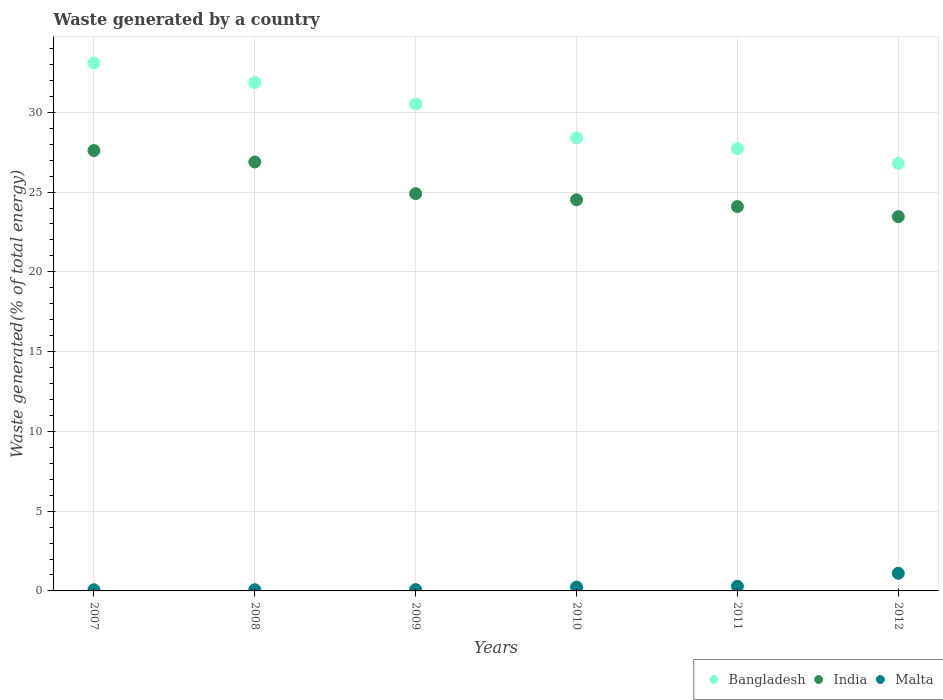What is the total waste generated in Malta in 2010?
Make the answer very short. 0.24. Across all years, what is the maximum total waste generated in Malta?
Provide a succinct answer. 1.11. Across all years, what is the minimum total waste generated in India?
Your response must be concise. 23.46. In which year was the total waste generated in Malta minimum?
Provide a short and direct response. 2007. What is the total total waste generated in Bangladesh in the graph?
Give a very brief answer. 178.39. What is the difference between the total waste generated in Malta in 2007 and that in 2010?
Provide a short and direct response. -0.17. What is the difference between the total waste generated in Malta in 2012 and the total waste generated in Bangladesh in 2008?
Give a very brief answer. -30.76. What is the average total waste generated in Bangladesh per year?
Offer a very short reply. 29.73. In the year 2011, what is the difference between the total waste generated in Bangladesh and total waste generated in India?
Provide a succinct answer. 3.63. In how many years, is the total waste generated in Bangladesh greater than 27 %?
Offer a terse response. 5. What is the ratio of the total waste generated in Malta in 2007 to that in 2008?
Give a very brief answer. 0.95. Is the total waste generated in India in 2007 less than that in 2012?
Your answer should be very brief. No. What is the difference between the highest and the second highest total waste generated in Malta?
Your answer should be compact. 0.82. What is the difference between the highest and the lowest total waste generated in India?
Your answer should be very brief. 4.14. Is the sum of the total waste generated in India in 2008 and 2009 greater than the maximum total waste generated in Malta across all years?
Keep it short and to the point. Yes. Is it the case that in every year, the sum of the total waste generated in Malta and total waste generated in India  is greater than the total waste generated in Bangladesh?
Your answer should be compact. No. Does the total waste generated in Bangladesh monotonically increase over the years?
Give a very brief answer. No. Is the total waste generated in Bangladesh strictly less than the total waste generated in India over the years?
Offer a very short reply. No. How many years are there in the graph?
Keep it short and to the point. 6. Are the values on the major ticks of Y-axis written in scientific E-notation?
Your response must be concise. No. Does the graph contain any zero values?
Your response must be concise. No. How are the legend labels stacked?
Provide a succinct answer. Horizontal. What is the title of the graph?
Make the answer very short. Waste generated by a country. What is the label or title of the X-axis?
Offer a very short reply. Years. What is the label or title of the Y-axis?
Keep it short and to the point. Waste generated(% of total energy). What is the Waste generated(% of total energy) in Bangladesh in 2007?
Provide a short and direct response. 33.09. What is the Waste generated(% of total energy) in India in 2007?
Your response must be concise. 27.6. What is the Waste generated(% of total energy) of Malta in 2007?
Provide a short and direct response. 0.07. What is the Waste generated(% of total energy) in Bangladesh in 2008?
Offer a terse response. 31.86. What is the Waste generated(% of total energy) in India in 2008?
Give a very brief answer. 26.88. What is the Waste generated(% of total energy) in Malta in 2008?
Your response must be concise. 0.07. What is the Waste generated(% of total energy) of Bangladesh in 2009?
Provide a succinct answer. 30.52. What is the Waste generated(% of total energy) in India in 2009?
Your response must be concise. 24.9. What is the Waste generated(% of total energy) of Malta in 2009?
Provide a succinct answer. 0.08. What is the Waste generated(% of total energy) of Bangladesh in 2010?
Your response must be concise. 28.4. What is the Waste generated(% of total energy) of India in 2010?
Make the answer very short. 24.51. What is the Waste generated(% of total energy) in Malta in 2010?
Provide a succinct answer. 0.24. What is the Waste generated(% of total energy) in Bangladesh in 2011?
Your answer should be compact. 27.72. What is the Waste generated(% of total energy) in India in 2011?
Give a very brief answer. 24.09. What is the Waste generated(% of total energy) of Malta in 2011?
Make the answer very short. 0.29. What is the Waste generated(% of total energy) of Bangladesh in 2012?
Give a very brief answer. 26.8. What is the Waste generated(% of total energy) of India in 2012?
Offer a very short reply. 23.46. What is the Waste generated(% of total energy) in Malta in 2012?
Ensure brevity in your answer.  1.11. Across all years, what is the maximum Waste generated(% of total energy) of Bangladesh?
Your answer should be compact. 33.09. Across all years, what is the maximum Waste generated(% of total energy) in India?
Your answer should be compact. 27.6. Across all years, what is the maximum Waste generated(% of total energy) in Malta?
Make the answer very short. 1.11. Across all years, what is the minimum Waste generated(% of total energy) in Bangladesh?
Provide a succinct answer. 26.8. Across all years, what is the minimum Waste generated(% of total energy) of India?
Your answer should be compact. 23.46. Across all years, what is the minimum Waste generated(% of total energy) in Malta?
Offer a very short reply. 0.07. What is the total Waste generated(% of total energy) in Bangladesh in the graph?
Your answer should be very brief. 178.39. What is the total Waste generated(% of total energy) in India in the graph?
Give a very brief answer. 151.45. What is the total Waste generated(% of total energy) in Malta in the graph?
Ensure brevity in your answer.  1.86. What is the difference between the Waste generated(% of total energy) of Bangladesh in 2007 and that in 2008?
Offer a terse response. 1.23. What is the difference between the Waste generated(% of total energy) in India in 2007 and that in 2008?
Your answer should be compact. 0.72. What is the difference between the Waste generated(% of total energy) in Malta in 2007 and that in 2008?
Your answer should be very brief. -0. What is the difference between the Waste generated(% of total energy) in Bangladesh in 2007 and that in 2009?
Your response must be concise. 2.58. What is the difference between the Waste generated(% of total energy) in India in 2007 and that in 2009?
Offer a very short reply. 2.7. What is the difference between the Waste generated(% of total energy) of Malta in 2007 and that in 2009?
Ensure brevity in your answer.  -0.01. What is the difference between the Waste generated(% of total energy) in Bangladesh in 2007 and that in 2010?
Your response must be concise. 4.7. What is the difference between the Waste generated(% of total energy) of India in 2007 and that in 2010?
Offer a very short reply. 3.09. What is the difference between the Waste generated(% of total energy) in Malta in 2007 and that in 2010?
Offer a terse response. -0.17. What is the difference between the Waste generated(% of total energy) in Bangladesh in 2007 and that in 2011?
Your answer should be very brief. 5.38. What is the difference between the Waste generated(% of total energy) in India in 2007 and that in 2011?
Give a very brief answer. 3.51. What is the difference between the Waste generated(% of total energy) of Malta in 2007 and that in 2011?
Your response must be concise. -0.22. What is the difference between the Waste generated(% of total energy) of Bangladesh in 2007 and that in 2012?
Offer a very short reply. 6.29. What is the difference between the Waste generated(% of total energy) in India in 2007 and that in 2012?
Your answer should be compact. 4.14. What is the difference between the Waste generated(% of total energy) of Malta in 2007 and that in 2012?
Make the answer very short. -1.04. What is the difference between the Waste generated(% of total energy) of Bangladesh in 2008 and that in 2009?
Give a very brief answer. 1.35. What is the difference between the Waste generated(% of total energy) in India in 2008 and that in 2009?
Ensure brevity in your answer.  1.98. What is the difference between the Waste generated(% of total energy) in Malta in 2008 and that in 2009?
Make the answer very short. -0.01. What is the difference between the Waste generated(% of total energy) in Bangladesh in 2008 and that in 2010?
Keep it short and to the point. 3.47. What is the difference between the Waste generated(% of total energy) of India in 2008 and that in 2010?
Give a very brief answer. 2.37. What is the difference between the Waste generated(% of total energy) of Malta in 2008 and that in 2010?
Offer a very short reply. -0.16. What is the difference between the Waste generated(% of total energy) in Bangladesh in 2008 and that in 2011?
Your answer should be very brief. 4.15. What is the difference between the Waste generated(% of total energy) of India in 2008 and that in 2011?
Offer a very short reply. 2.79. What is the difference between the Waste generated(% of total energy) in Malta in 2008 and that in 2011?
Provide a short and direct response. -0.22. What is the difference between the Waste generated(% of total energy) of Bangladesh in 2008 and that in 2012?
Ensure brevity in your answer.  5.06. What is the difference between the Waste generated(% of total energy) in India in 2008 and that in 2012?
Give a very brief answer. 3.42. What is the difference between the Waste generated(% of total energy) in Malta in 2008 and that in 2012?
Your answer should be very brief. -1.03. What is the difference between the Waste generated(% of total energy) of Bangladesh in 2009 and that in 2010?
Your answer should be compact. 2.12. What is the difference between the Waste generated(% of total energy) of India in 2009 and that in 2010?
Make the answer very short. 0.39. What is the difference between the Waste generated(% of total energy) in Malta in 2009 and that in 2010?
Give a very brief answer. -0.16. What is the difference between the Waste generated(% of total energy) in Bangladesh in 2009 and that in 2011?
Your answer should be very brief. 2.8. What is the difference between the Waste generated(% of total energy) of India in 2009 and that in 2011?
Keep it short and to the point. 0.81. What is the difference between the Waste generated(% of total energy) of Malta in 2009 and that in 2011?
Your answer should be very brief. -0.21. What is the difference between the Waste generated(% of total energy) in Bangladesh in 2009 and that in 2012?
Your answer should be very brief. 3.72. What is the difference between the Waste generated(% of total energy) of India in 2009 and that in 2012?
Your response must be concise. 1.44. What is the difference between the Waste generated(% of total energy) of Malta in 2009 and that in 2012?
Offer a very short reply. -1.03. What is the difference between the Waste generated(% of total energy) of Bangladesh in 2010 and that in 2011?
Your response must be concise. 0.68. What is the difference between the Waste generated(% of total energy) in India in 2010 and that in 2011?
Give a very brief answer. 0.42. What is the difference between the Waste generated(% of total energy) in Malta in 2010 and that in 2011?
Your answer should be very brief. -0.05. What is the difference between the Waste generated(% of total energy) in Bangladesh in 2010 and that in 2012?
Ensure brevity in your answer.  1.6. What is the difference between the Waste generated(% of total energy) of India in 2010 and that in 2012?
Your response must be concise. 1.05. What is the difference between the Waste generated(% of total energy) of Malta in 2010 and that in 2012?
Make the answer very short. -0.87. What is the difference between the Waste generated(% of total energy) of Bangladesh in 2011 and that in 2012?
Your answer should be compact. 0.92. What is the difference between the Waste generated(% of total energy) of India in 2011 and that in 2012?
Offer a very short reply. 0.63. What is the difference between the Waste generated(% of total energy) of Malta in 2011 and that in 2012?
Ensure brevity in your answer.  -0.82. What is the difference between the Waste generated(% of total energy) in Bangladesh in 2007 and the Waste generated(% of total energy) in India in 2008?
Provide a short and direct response. 6.21. What is the difference between the Waste generated(% of total energy) of Bangladesh in 2007 and the Waste generated(% of total energy) of Malta in 2008?
Keep it short and to the point. 33.02. What is the difference between the Waste generated(% of total energy) in India in 2007 and the Waste generated(% of total energy) in Malta in 2008?
Ensure brevity in your answer.  27.53. What is the difference between the Waste generated(% of total energy) in Bangladesh in 2007 and the Waste generated(% of total energy) in India in 2009?
Keep it short and to the point. 8.19. What is the difference between the Waste generated(% of total energy) in Bangladesh in 2007 and the Waste generated(% of total energy) in Malta in 2009?
Ensure brevity in your answer.  33.01. What is the difference between the Waste generated(% of total energy) of India in 2007 and the Waste generated(% of total energy) of Malta in 2009?
Offer a very short reply. 27.52. What is the difference between the Waste generated(% of total energy) of Bangladesh in 2007 and the Waste generated(% of total energy) of India in 2010?
Provide a succinct answer. 8.58. What is the difference between the Waste generated(% of total energy) of Bangladesh in 2007 and the Waste generated(% of total energy) of Malta in 2010?
Ensure brevity in your answer.  32.86. What is the difference between the Waste generated(% of total energy) in India in 2007 and the Waste generated(% of total energy) in Malta in 2010?
Keep it short and to the point. 27.36. What is the difference between the Waste generated(% of total energy) in Bangladesh in 2007 and the Waste generated(% of total energy) in India in 2011?
Ensure brevity in your answer.  9. What is the difference between the Waste generated(% of total energy) in Bangladesh in 2007 and the Waste generated(% of total energy) in Malta in 2011?
Your response must be concise. 32.8. What is the difference between the Waste generated(% of total energy) of India in 2007 and the Waste generated(% of total energy) of Malta in 2011?
Make the answer very short. 27.31. What is the difference between the Waste generated(% of total energy) of Bangladesh in 2007 and the Waste generated(% of total energy) of India in 2012?
Offer a terse response. 9.63. What is the difference between the Waste generated(% of total energy) of Bangladesh in 2007 and the Waste generated(% of total energy) of Malta in 2012?
Offer a very short reply. 31.99. What is the difference between the Waste generated(% of total energy) of India in 2007 and the Waste generated(% of total energy) of Malta in 2012?
Provide a succinct answer. 26.49. What is the difference between the Waste generated(% of total energy) in Bangladesh in 2008 and the Waste generated(% of total energy) in India in 2009?
Keep it short and to the point. 6.96. What is the difference between the Waste generated(% of total energy) in Bangladesh in 2008 and the Waste generated(% of total energy) in Malta in 2009?
Your response must be concise. 31.78. What is the difference between the Waste generated(% of total energy) of India in 2008 and the Waste generated(% of total energy) of Malta in 2009?
Offer a very short reply. 26.8. What is the difference between the Waste generated(% of total energy) of Bangladesh in 2008 and the Waste generated(% of total energy) of India in 2010?
Offer a very short reply. 7.35. What is the difference between the Waste generated(% of total energy) in Bangladesh in 2008 and the Waste generated(% of total energy) in Malta in 2010?
Keep it short and to the point. 31.63. What is the difference between the Waste generated(% of total energy) of India in 2008 and the Waste generated(% of total energy) of Malta in 2010?
Offer a terse response. 26.65. What is the difference between the Waste generated(% of total energy) of Bangladesh in 2008 and the Waste generated(% of total energy) of India in 2011?
Give a very brief answer. 7.77. What is the difference between the Waste generated(% of total energy) in Bangladesh in 2008 and the Waste generated(% of total energy) in Malta in 2011?
Provide a short and direct response. 31.57. What is the difference between the Waste generated(% of total energy) of India in 2008 and the Waste generated(% of total energy) of Malta in 2011?
Your answer should be compact. 26.59. What is the difference between the Waste generated(% of total energy) in Bangladesh in 2008 and the Waste generated(% of total energy) in India in 2012?
Keep it short and to the point. 8.4. What is the difference between the Waste generated(% of total energy) in Bangladesh in 2008 and the Waste generated(% of total energy) in Malta in 2012?
Your answer should be very brief. 30.76. What is the difference between the Waste generated(% of total energy) in India in 2008 and the Waste generated(% of total energy) in Malta in 2012?
Provide a succinct answer. 25.78. What is the difference between the Waste generated(% of total energy) in Bangladesh in 2009 and the Waste generated(% of total energy) in India in 2010?
Provide a succinct answer. 6. What is the difference between the Waste generated(% of total energy) in Bangladesh in 2009 and the Waste generated(% of total energy) in Malta in 2010?
Provide a succinct answer. 30.28. What is the difference between the Waste generated(% of total energy) of India in 2009 and the Waste generated(% of total energy) of Malta in 2010?
Keep it short and to the point. 24.66. What is the difference between the Waste generated(% of total energy) in Bangladesh in 2009 and the Waste generated(% of total energy) in India in 2011?
Your answer should be very brief. 6.43. What is the difference between the Waste generated(% of total energy) of Bangladesh in 2009 and the Waste generated(% of total energy) of Malta in 2011?
Your answer should be very brief. 30.23. What is the difference between the Waste generated(% of total energy) in India in 2009 and the Waste generated(% of total energy) in Malta in 2011?
Your answer should be compact. 24.61. What is the difference between the Waste generated(% of total energy) in Bangladesh in 2009 and the Waste generated(% of total energy) in India in 2012?
Offer a very short reply. 7.06. What is the difference between the Waste generated(% of total energy) in Bangladesh in 2009 and the Waste generated(% of total energy) in Malta in 2012?
Give a very brief answer. 29.41. What is the difference between the Waste generated(% of total energy) in India in 2009 and the Waste generated(% of total energy) in Malta in 2012?
Keep it short and to the point. 23.79. What is the difference between the Waste generated(% of total energy) of Bangladesh in 2010 and the Waste generated(% of total energy) of India in 2011?
Offer a very short reply. 4.31. What is the difference between the Waste generated(% of total energy) of Bangladesh in 2010 and the Waste generated(% of total energy) of Malta in 2011?
Keep it short and to the point. 28.1. What is the difference between the Waste generated(% of total energy) in India in 2010 and the Waste generated(% of total energy) in Malta in 2011?
Keep it short and to the point. 24.22. What is the difference between the Waste generated(% of total energy) in Bangladesh in 2010 and the Waste generated(% of total energy) in India in 2012?
Offer a terse response. 4.94. What is the difference between the Waste generated(% of total energy) of Bangladesh in 2010 and the Waste generated(% of total energy) of Malta in 2012?
Offer a terse response. 27.29. What is the difference between the Waste generated(% of total energy) of India in 2010 and the Waste generated(% of total energy) of Malta in 2012?
Provide a succinct answer. 23.41. What is the difference between the Waste generated(% of total energy) in Bangladesh in 2011 and the Waste generated(% of total energy) in India in 2012?
Ensure brevity in your answer.  4.26. What is the difference between the Waste generated(% of total energy) of Bangladesh in 2011 and the Waste generated(% of total energy) of Malta in 2012?
Ensure brevity in your answer.  26.61. What is the difference between the Waste generated(% of total energy) of India in 2011 and the Waste generated(% of total energy) of Malta in 2012?
Provide a succinct answer. 22.98. What is the average Waste generated(% of total energy) of Bangladesh per year?
Make the answer very short. 29.73. What is the average Waste generated(% of total energy) in India per year?
Offer a very short reply. 25.24. What is the average Waste generated(% of total energy) of Malta per year?
Offer a terse response. 0.31. In the year 2007, what is the difference between the Waste generated(% of total energy) of Bangladesh and Waste generated(% of total energy) of India?
Provide a succinct answer. 5.49. In the year 2007, what is the difference between the Waste generated(% of total energy) of Bangladesh and Waste generated(% of total energy) of Malta?
Provide a succinct answer. 33.02. In the year 2007, what is the difference between the Waste generated(% of total energy) of India and Waste generated(% of total energy) of Malta?
Offer a very short reply. 27.53. In the year 2008, what is the difference between the Waste generated(% of total energy) in Bangladesh and Waste generated(% of total energy) in India?
Your answer should be very brief. 4.98. In the year 2008, what is the difference between the Waste generated(% of total energy) in Bangladesh and Waste generated(% of total energy) in Malta?
Your response must be concise. 31.79. In the year 2008, what is the difference between the Waste generated(% of total energy) of India and Waste generated(% of total energy) of Malta?
Provide a succinct answer. 26.81. In the year 2009, what is the difference between the Waste generated(% of total energy) in Bangladesh and Waste generated(% of total energy) in India?
Provide a succinct answer. 5.62. In the year 2009, what is the difference between the Waste generated(% of total energy) of Bangladesh and Waste generated(% of total energy) of Malta?
Your answer should be very brief. 30.44. In the year 2009, what is the difference between the Waste generated(% of total energy) of India and Waste generated(% of total energy) of Malta?
Make the answer very short. 24.82. In the year 2010, what is the difference between the Waste generated(% of total energy) in Bangladesh and Waste generated(% of total energy) in India?
Keep it short and to the point. 3.88. In the year 2010, what is the difference between the Waste generated(% of total energy) in Bangladesh and Waste generated(% of total energy) in Malta?
Make the answer very short. 28.16. In the year 2010, what is the difference between the Waste generated(% of total energy) in India and Waste generated(% of total energy) in Malta?
Your answer should be very brief. 24.27. In the year 2011, what is the difference between the Waste generated(% of total energy) in Bangladesh and Waste generated(% of total energy) in India?
Keep it short and to the point. 3.63. In the year 2011, what is the difference between the Waste generated(% of total energy) of Bangladesh and Waste generated(% of total energy) of Malta?
Offer a very short reply. 27.43. In the year 2011, what is the difference between the Waste generated(% of total energy) of India and Waste generated(% of total energy) of Malta?
Provide a short and direct response. 23.8. In the year 2012, what is the difference between the Waste generated(% of total energy) in Bangladesh and Waste generated(% of total energy) in India?
Provide a succinct answer. 3.34. In the year 2012, what is the difference between the Waste generated(% of total energy) of Bangladesh and Waste generated(% of total energy) of Malta?
Provide a succinct answer. 25.69. In the year 2012, what is the difference between the Waste generated(% of total energy) in India and Waste generated(% of total energy) in Malta?
Make the answer very short. 22.35. What is the ratio of the Waste generated(% of total energy) of Bangladesh in 2007 to that in 2008?
Provide a succinct answer. 1.04. What is the ratio of the Waste generated(% of total energy) in India in 2007 to that in 2008?
Your answer should be very brief. 1.03. What is the ratio of the Waste generated(% of total energy) of Malta in 2007 to that in 2008?
Offer a terse response. 0.95. What is the ratio of the Waste generated(% of total energy) of Bangladesh in 2007 to that in 2009?
Ensure brevity in your answer.  1.08. What is the ratio of the Waste generated(% of total energy) in India in 2007 to that in 2009?
Your answer should be very brief. 1.11. What is the ratio of the Waste generated(% of total energy) of Malta in 2007 to that in 2009?
Your answer should be compact. 0.89. What is the ratio of the Waste generated(% of total energy) in Bangladesh in 2007 to that in 2010?
Provide a short and direct response. 1.17. What is the ratio of the Waste generated(% of total energy) of India in 2007 to that in 2010?
Keep it short and to the point. 1.13. What is the ratio of the Waste generated(% of total energy) of Malta in 2007 to that in 2010?
Offer a terse response. 0.3. What is the ratio of the Waste generated(% of total energy) in Bangladesh in 2007 to that in 2011?
Your answer should be very brief. 1.19. What is the ratio of the Waste generated(% of total energy) in India in 2007 to that in 2011?
Your response must be concise. 1.15. What is the ratio of the Waste generated(% of total energy) in Malta in 2007 to that in 2011?
Offer a very short reply. 0.24. What is the ratio of the Waste generated(% of total energy) in Bangladesh in 2007 to that in 2012?
Ensure brevity in your answer.  1.23. What is the ratio of the Waste generated(% of total energy) in India in 2007 to that in 2012?
Your answer should be very brief. 1.18. What is the ratio of the Waste generated(% of total energy) in Malta in 2007 to that in 2012?
Offer a terse response. 0.06. What is the ratio of the Waste generated(% of total energy) in Bangladesh in 2008 to that in 2009?
Your answer should be compact. 1.04. What is the ratio of the Waste generated(% of total energy) of India in 2008 to that in 2009?
Keep it short and to the point. 1.08. What is the ratio of the Waste generated(% of total energy) in Malta in 2008 to that in 2009?
Keep it short and to the point. 0.93. What is the ratio of the Waste generated(% of total energy) in Bangladesh in 2008 to that in 2010?
Make the answer very short. 1.12. What is the ratio of the Waste generated(% of total energy) in India in 2008 to that in 2010?
Give a very brief answer. 1.1. What is the ratio of the Waste generated(% of total energy) of Malta in 2008 to that in 2010?
Your response must be concise. 0.31. What is the ratio of the Waste generated(% of total energy) in Bangladesh in 2008 to that in 2011?
Your answer should be very brief. 1.15. What is the ratio of the Waste generated(% of total energy) in India in 2008 to that in 2011?
Offer a terse response. 1.12. What is the ratio of the Waste generated(% of total energy) of Malta in 2008 to that in 2011?
Your answer should be compact. 0.25. What is the ratio of the Waste generated(% of total energy) of Bangladesh in 2008 to that in 2012?
Ensure brevity in your answer.  1.19. What is the ratio of the Waste generated(% of total energy) in India in 2008 to that in 2012?
Provide a succinct answer. 1.15. What is the ratio of the Waste generated(% of total energy) in Malta in 2008 to that in 2012?
Your answer should be very brief. 0.07. What is the ratio of the Waste generated(% of total energy) in Bangladesh in 2009 to that in 2010?
Your response must be concise. 1.07. What is the ratio of the Waste generated(% of total energy) in India in 2009 to that in 2010?
Offer a very short reply. 1.02. What is the ratio of the Waste generated(% of total energy) in Malta in 2009 to that in 2010?
Keep it short and to the point. 0.34. What is the ratio of the Waste generated(% of total energy) of Bangladesh in 2009 to that in 2011?
Offer a terse response. 1.1. What is the ratio of the Waste generated(% of total energy) in India in 2009 to that in 2011?
Give a very brief answer. 1.03. What is the ratio of the Waste generated(% of total energy) of Malta in 2009 to that in 2011?
Your response must be concise. 0.27. What is the ratio of the Waste generated(% of total energy) of Bangladesh in 2009 to that in 2012?
Provide a short and direct response. 1.14. What is the ratio of the Waste generated(% of total energy) in India in 2009 to that in 2012?
Your answer should be very brief. 1.06. What is the ratio of the Waste generated(% of total energy) of Malta in 2009 to that in 2012?
Ensure brevity in your answer.  0.07. What is the ratio of the Waste generated(% of total energy) of Bangladesh in 2010 to that in 2011?
Keep it short and to the point. 1.02. What is the ratio of the Waste generated(% of total energy) in India in 2010 to that in 2011?
Provide a succinct answer. 1.02. What is the ratio of the Waste generated(% of total energy) in Malta in 2010 to that in 2011?
Your response must be concise. 0.82. What is the ratio of the Waste generated(% of total energy) of Bangladesh in 2010 to that in 2012?
Offer a terse response. 1.06. What is the ratio of the Waste generated(% of total energy) in India in 2010 to that in 2012?
Your response must be concise. 1.04. What is the ratio of the Waste generated(% of total energy) in Malta in 2010 to that in 2012?
Keep it short and to the point. 0.22. What is the ratio of the Waste generated(% of total energy) of Bangladesh in 2011 to that in 2012?
Your response must be concise. 1.03. What is the ratio of the Waste generated(% of total energy) of India in 2011 to that in 2012?
Ensure brevity in your answer.  1.03. What is the ratio of the Waste generated(% of total energy) in Malta in 2011 to that in 2012?
Ensure brevity in your answer.  0.26. What is the difference between the highest and the second highest Waste generated(% of total energy) of Bangladesh?
Your answer should be compact. 1.23. What is the difference between the highest and the second highest Waste generated(% of total energy) of India?
Make the answer very short. 0.72. What is the difference between the highest and the second highest Waste generated(% of total energy) of Malta?
Provide a short and direct response. 0.82. What is the difference between the highest and the lowest Waste generated(% of total energy) in Bangladesh?
Provide a short and direct response. 6.29. What is the difference between the highest and the lowest Waste generated(% of total energy) in India?
Provide a succinct answer. 4.14. What is the difference between the highest and the lowest Waste generated(% of total energy) in Malta?
Give a very brief answer. 1.04. 